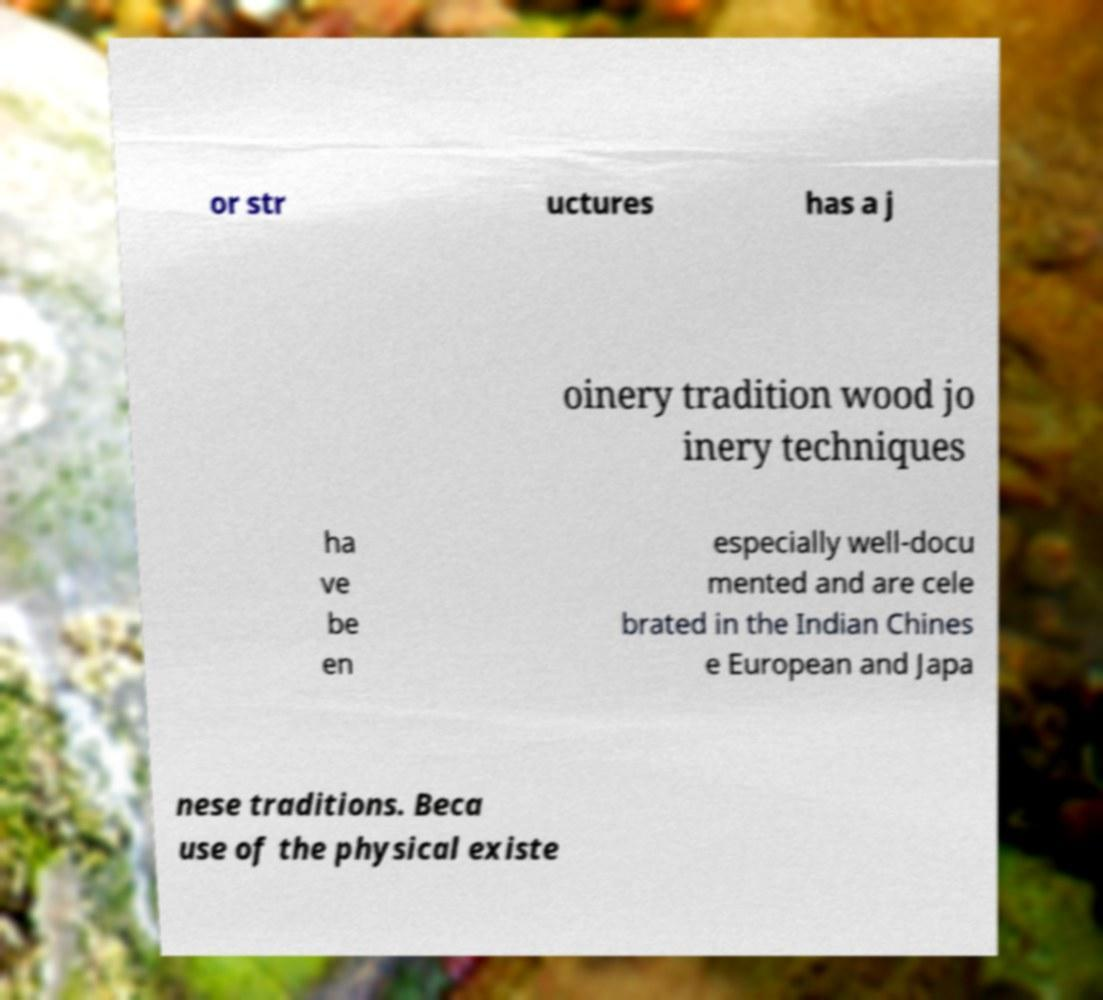Could you assist in decoding the text presented in this image and type it out clearly? or str uctures has a j oinery tradition wood jo inery techniques ha ve be en especially well-docu mented and are cele brated in the Indian Chines e European and Japa nese traditions. Beca use of the physical existe 